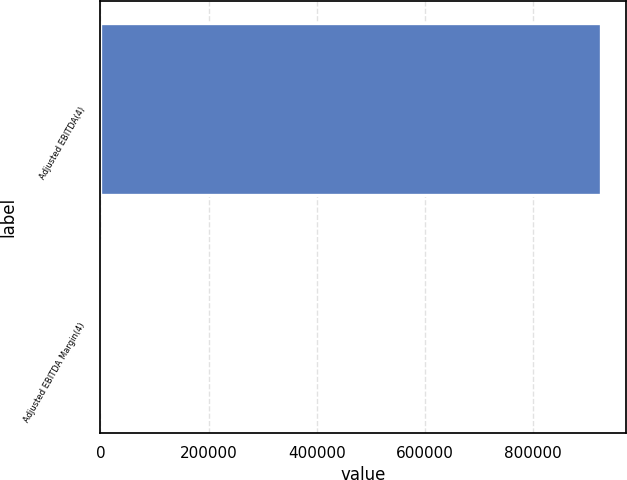Convert chart to OTSL. <chart><loc_0><loc_0><loc_500><loc_500><bar_chart><fcel>Adjusted EBITDA(4)<fcel>Adjusted EBITDA Margin(4)<nl><fcel>925797<fcel>29.7<nl></chart> 